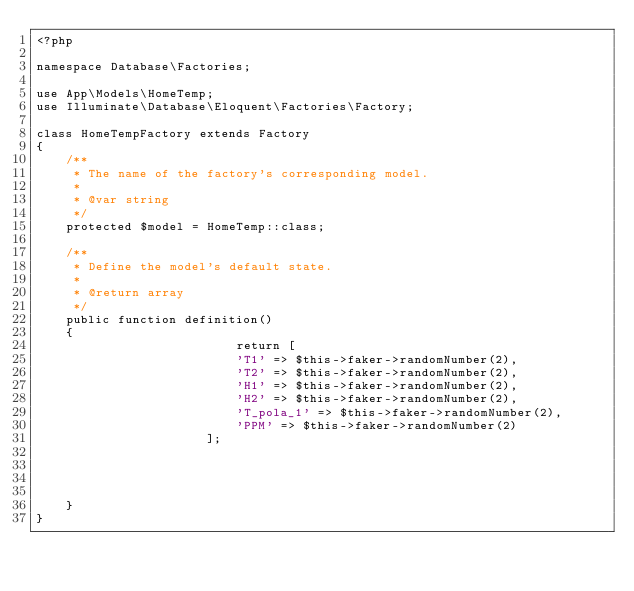Convert code to text. <code><loc_0><loc_0><loc_500><loc_500><_PHP_><?php

namespace Database\Factories;

use App\Models\HomeTemp;
use Illuminate\Database\Eloquent\Factories\Factory;

class HomeTempFactory extends Factory
{
    /**
     * The name of the factory's corresponding model.
     *
     * @var string
     */
    protected $model = HomeTemp::class;

    /**
     * Define the model's default state.
     *
     * @return array
     */
    public function definition()
    {
                           return [
                           'T1' => $this->faker->randomNumber(2),
                           'T2' => $this->faker->randomNumber(2),
                           'H1' => $this->faker->randomNumber(2),
                           'H2' => $this->faker->randomNumber(2),
                           'T_pola_1' => $this->faker->randomNumber(2),
                           'PPM' => $this->faker->randomNumber(2)
                       ];




    }
}
</code> 